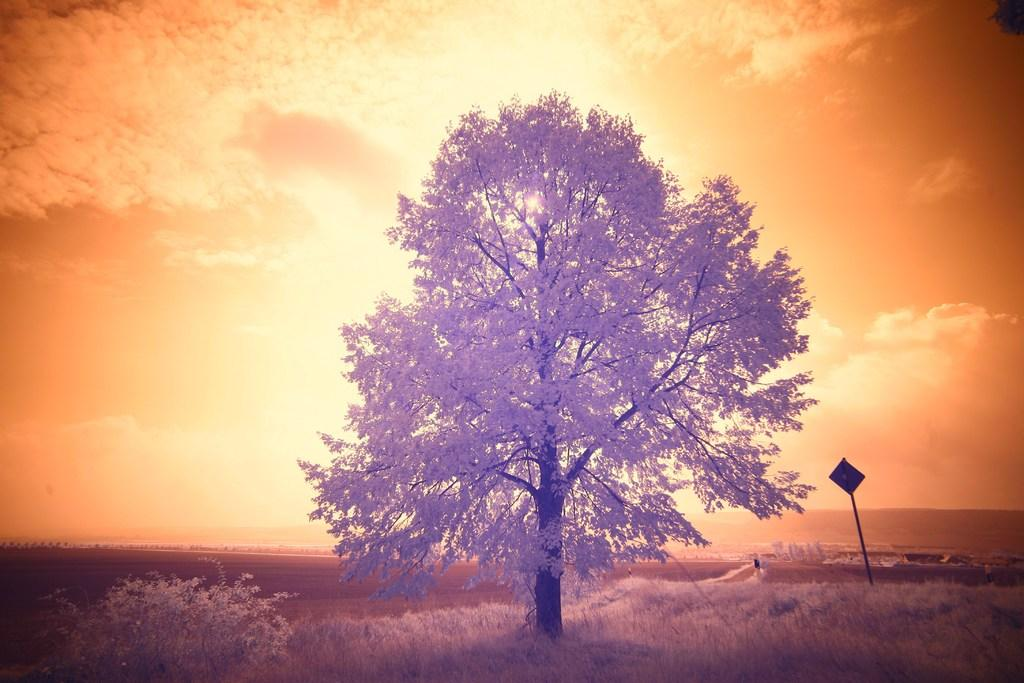What type of vegetation can be seen in the image? There are trees and plants in the image. Are there any man-made objects in the image? Yes, there are signs in the image. What is the condition of the sky in the image? The sky is visible in the image and appears to be cloudy. What type of wine is being served at the selection in the image? There is no wine or selection present in the image; it features trees, plants, signs, and a cloudy sky. 